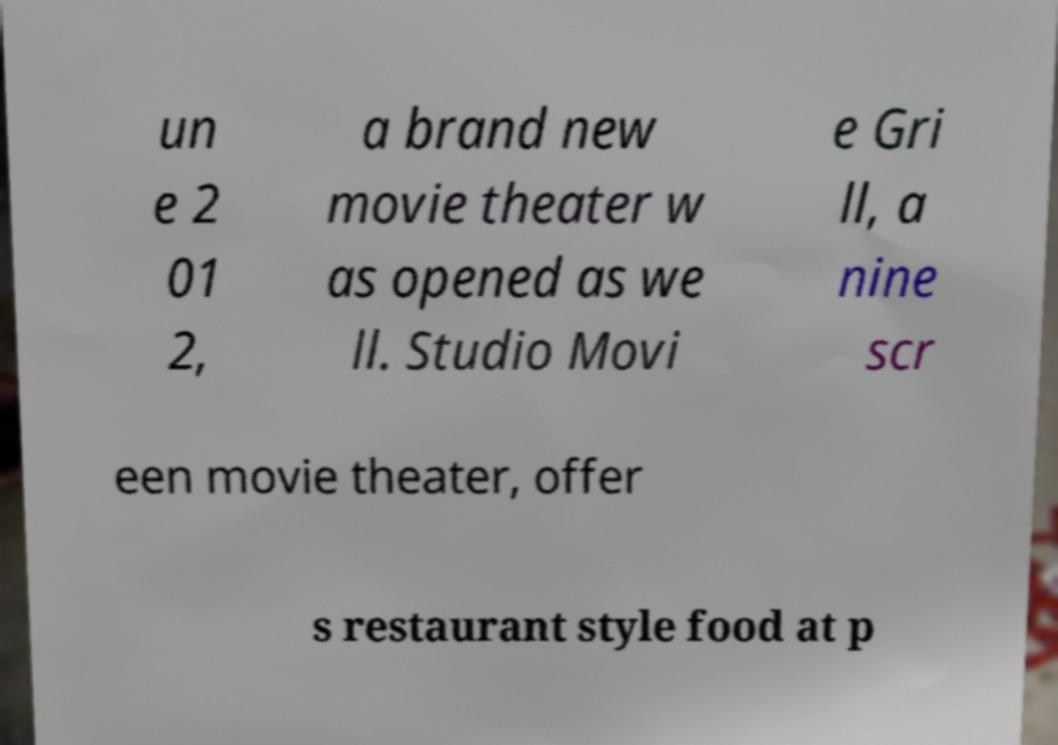I need the written content from this picture converted into text. Can you do that? un e 2 01 2, a brand new movie theater w as opened as we ll. Studio Movi e Gri ll, a nine scr een movie theater, offer s restaurant style food at p 